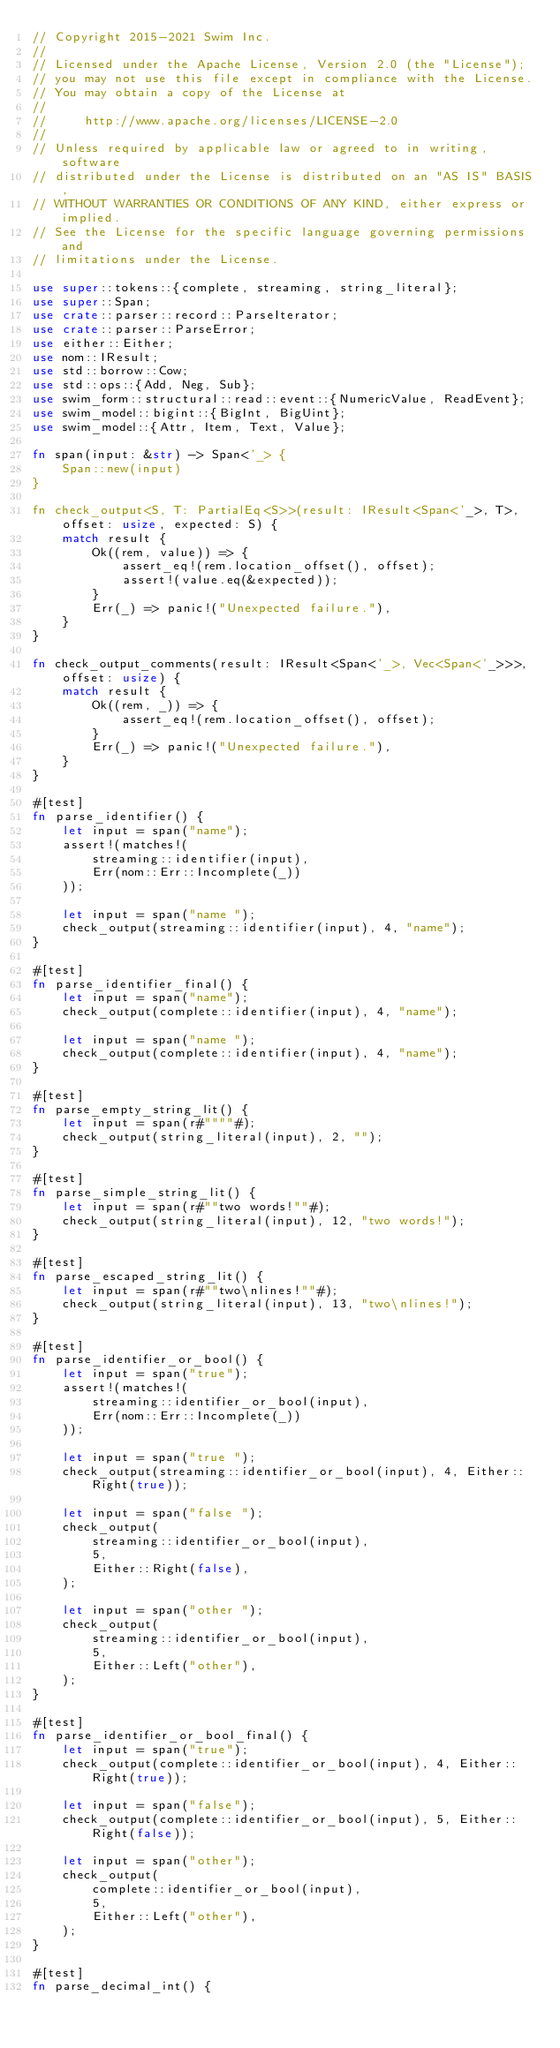Convert code to text. <code><loc_0><loc_0><loc_500><loc_500><_Rust_>// Copyright 2015-2021 Swim Inc.
//
// Licensed under the Apache License, Version 2.0 (the "License");
// you may not use this file except in compliance with the License.
// You may obtain a copy of the License at
//
//     http://www.apache.org/licenses/LICENSE-2.0
//
// Unless required by applicable law or agreed to in writing, software
// distributed under the License is distributed on an "AS IS" BASIS,
// WITHOUT WARRANTIES OR CONDITIONS OF ANY KIND, either express or implied.
// See the License for the specific language governing permissions and
// limitations under the License.

use super::tokens::{complete, streaming, string_literal};
use super::Span;
use crate::parser::record::ParseIterator;
use crate::parser::ParseError;
use either::Either;
use nom::IResult;
use std::borrow::Cow;
use std::ops::{Add, Neg, Sub};
use swim_form::structural::read::event::{NumericValue, ReadEvent};
use swim_model::bigint::{BigInt, BigUint};
use swim_model::{Attr, Item, Text, Value};

fn span(input: &str) -> Span<'_> {
    Span::new(input)
}

fn check_output<S, T: PartialEq<S>>(result: IResult<Span<'_>, T>, offset: usize, expected: S) {
    match result {
        Ok((rem, value)) => {
            assert_eq!(rem.location_offset(), offset);
            assert!(value.eq(&expected));
        }
        Err(_) => panic!("Unexpected failure."),
    }
}

fn check_output_comments(result: IResult<Span<'_>, Vec<Span<'_>>>, offset: usize) {
    match result {
        Ok((rem, _)) => {
            assert_eq!(rem.location_offset(), offset);
        }
        Err(_) => panic!("Unexpected failure."),
    }
}

#[test]
fn parse_identifier() {
    let input = span("name");
    assert!(matches!(
        streaming::identifier(input),
        Err(nom::Err::Incomplete(_))
    ));

    let input = span("name ");
    check_output(streaming::identifier(input), 4, "name");
}

#[test]
fn parse_identifier_final() {
    let input = span("name");
    check_output(complete::identifier(input), 4, "name");

    let input = span("name ");
    check_output(complete::identifier(input), 4, "name");
}

#[test]
fn parse_empty_string_lit() {
    let input = span(r#""""#);
    check_output(string_literal(input), 2, "");
}

#[test]
fn parse_simple_string_lit() {
    let input = span(r#""two words!""#);
    check_output(string_literal(input), 12, "two words!");
}

#[test]
fn parse_escaped_string_lit() {
    let input = span(r#""two\nlines!""#);
    check_output(string_literal(input), 13, "two\nlines!");
}

#[test]
fn parse_identifier_or_bool() {
    let input = span("true");
    assert!(matches!(
        streaming::identifier_or_bool(input),
        Err(nom::Err::Incomplete(_))
    ));

    let input = span("true ");
    check_output(streaming::identifier_or_bool(input), 4, Either::Right(true));

    let input = span("false ");
    check_output(
        streaming::identifier_or_bool(input),
        5,
        Either::Right(false),
    );

    let input = span("other ");
    check_output(
        streaming::identifier_or_bool(input),
        5,
        Either::Left("other"),
    );
}

#[test]
fn parse_identifier_or_bool_final() {
    let input = span("true");
    check_output(complete::identifier_or_bool(input), 4, Either::Right(true));

    let input = span("false");
    check_output(complete::identifier_or_bool(input), 5, Either::Right(false));

    let input = span("other");
    check_output(
        complete::identifier_or_bool(input),
        5,
        Either::Left("other"),
    );
}

#[test]
fn parse_decimal_int() {</code> 